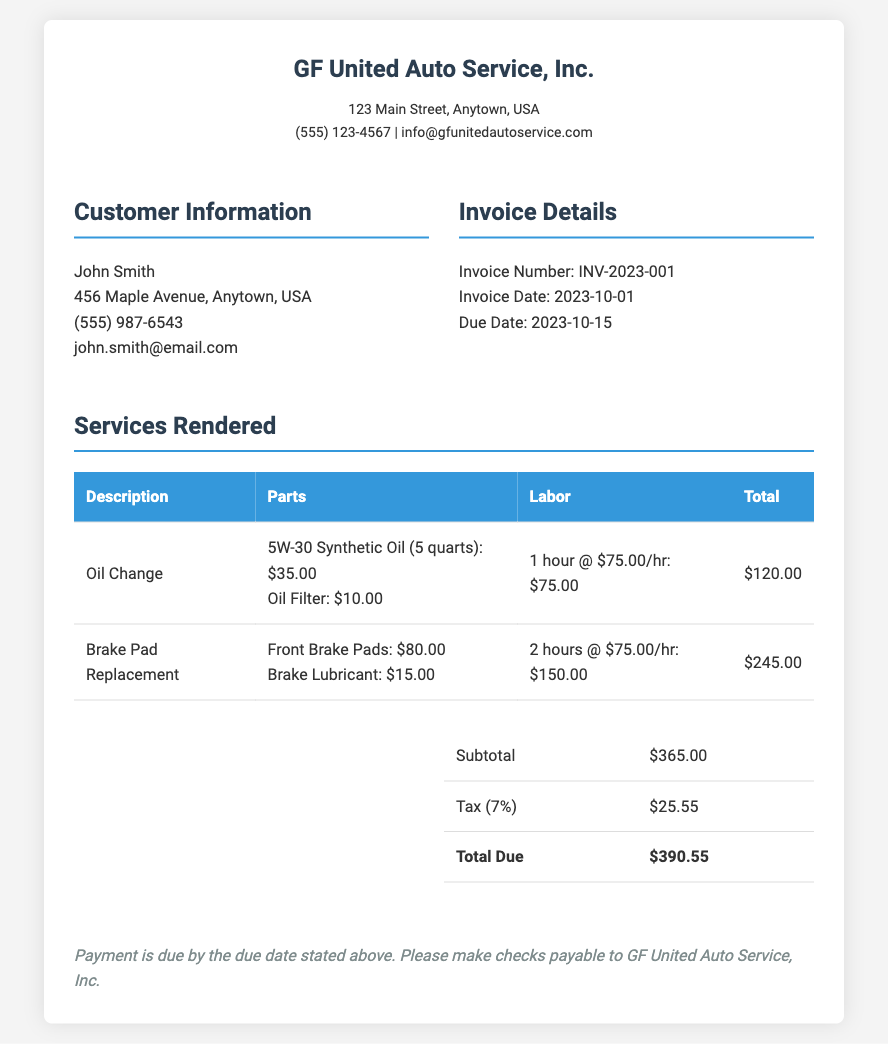What is the invoice number? The invoice number is specifically stated in the invoice details section.
Answer: INV-2023-001 What is the total due amount? The total due amount is calculated from the subtotal and tax, found in the summary section.
Answer: $390.55 Who is the customer? The customer's name is listed in the customer information section.
Answer: John Smith What is the tax rate applied? The tax rate is indicated next to the tax calculation in the summary table.
Answer: 7% How much do the brake pads cost? The cost of the brake pads is detailed in the services rendered table under parts.
Answer: $80.00 What is the labor cost for the oil change? The labor cost for the oil change can be found in the services rendered table.
Answer: $75.00 What is the due date for payment? The due date is specified in the invoice details section.
Answer: 2023-10-15 How many quarts of oil were used? The quantity of oil used is mentioned in the description of the oil change service.
Answer: 5 quarts What is the subtotal amount? The subtotal is presented in the summary table before tax.
Answer: $365.00 